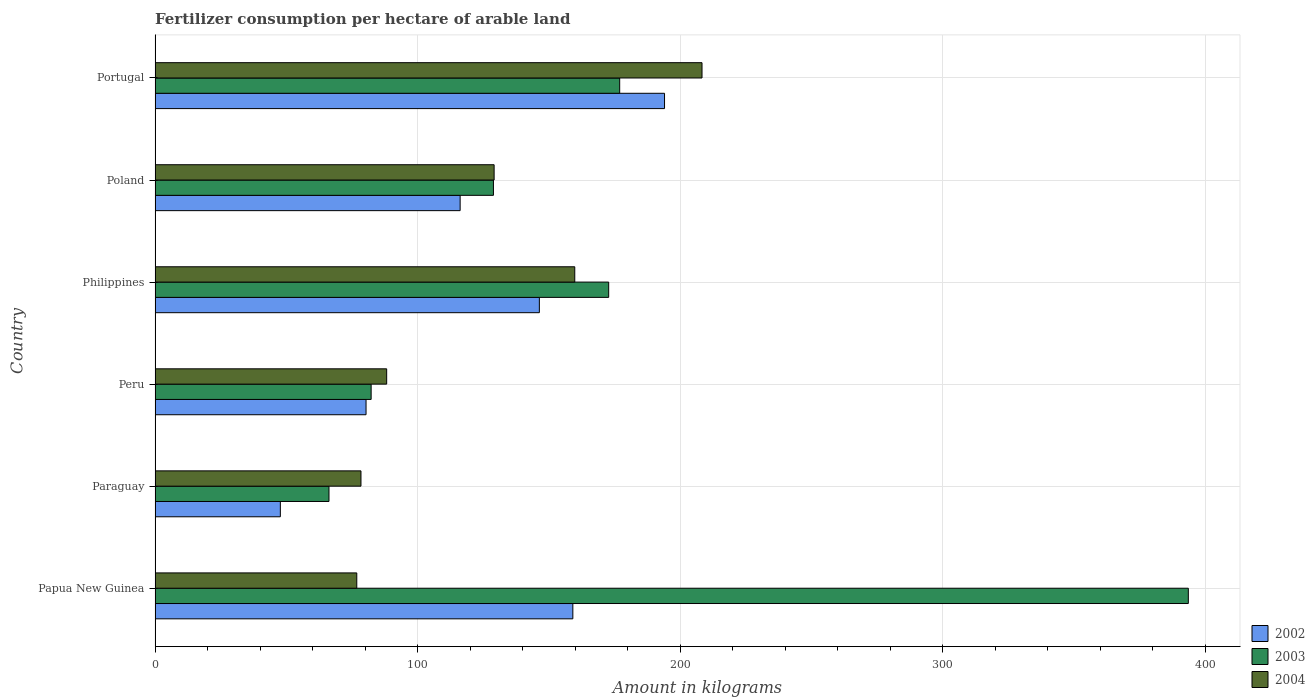How many different coloured bars are there?
Make the answer very short. 3. How many groups of bars are there?
Provide a short and direct response. 6. How many bars are there on the 6th tick from the top?
Provide a short and direct response. 3. How many bars are there on the 1st tick from the bottom?
Your answer should be compact. 3. What is the label of the 4th group of bars from the top?
Keep it short and to the point. Peru. What is the amount of fertilizer consumption in 2002 in Peru?
Your response must be concise. 80.35. Across all countries, what is the maximum amount of fertilizer consumption in 2003?
Offer a terse response. 393.53. Across all countries, what is the minimum amount of fertilizer consumption in 2002?
Your answer should be compact. 47.72. In which country was the amount of fertilizer consumption in 2003 maximum?
Provide a succinct answer. Papua New Guinea. In which country was the amount of fertilizer consumption in 2002 minimum?
Your response must be concise. Paraguay. What is the total amount of fertilizer consumption in 2003 in the graph?
Keep it short and to the point. 1020.66. What is the difference between the amount of fertilizer consumption in 2003 in Papua New Guinea and that in Peru?
Ensure brevity in your answer.  311.23. What is the difference between the amount of fertilizer consumption in 2002 in Poland and the amount of fertilizer consumption in 2003 in Paraguay?
Offer a terse response. 49.96. What is the average amount of fertilizer consumption in 2004 per country?
Offer a very short reply. 123.46. What is the difference between the amount of fertilizer consumption in 2004 and amount of fertilizer consumption in 2002 in Peru?
Offer a very short reply. 7.86. What is the ratio of the amount of fertilizer consumption in 2003 in Peru to that in Portugal?
Your response must be concise. 0.47. Is the amount of fertilizer consumption in 2004 in Philippines less than that in Portugal?
Your answer should be compact. Yes. Is the difference between the amount of fertilizer consumption in 2004 in Papua New Guinea and Peru greater than the difference between the amount of fertilizer consumption in 2002 in Papua New Guinea and Peru?
Keep it short and to the point. No. What is the difference between the highest and the second highest amount of fertilizer consumption in 2004?
Give a very brief answer. 48.47. What is the difference between the highest and the lowest amount of fertilizer consumption in 2003?
Offer a very short reply. 327.29. In how many countries, is the amount of fertilizer consumption in 2004 greater than the average amount of fertilizer consumption in 2004 taken over all countries?
Keep it short and to the point. 3. What does the 3rd bar from the top in Poland represents?
Give a very brief answer. 2002. What does the 1st bar from the bottom in Paraguay represents?
Provide a short and direct response. 2002. Is it the case that in every country, the sum of the amount of fertilizer consumption in 2003 and amount of fertilizer consumption in 2004 is greater than the amount of fertilizer consumption in 2002?
Your response must be concise. Yes. How many bars are there?
Keep it short and to the point. 18. Are all the bars in the graph horizontal?
Give a very brief answer. Yes. How many legend labels are there?
Provide a short and direct response. 3. How are the legend labels stacked?
Your answer should be very brief. Vertical. What is the title of the graph?
Make the answer very short. Fertilizer consumption per hectare of arable land. What is the label or title of the X-axis?
Ensure brevity in your answer.  Amount in kilograms. What is the Amount in kilograms of 2002 in Papua New Guinea?
Give a very brief answer. 159.12. What is the Amount in kilograms of 2003 in Papua New Guinea?
Your response must be concise. 393.53. What is the Amount in kilograms of 2004 in Papua New Guinea?
Your answer should be compact. 76.83. What is the Amount in kilograms of 2002 in Paraguay?
Keep it short and to the point. 47.72. What is the Amount in kilograms in 2003 in Paraguay?
Give a very brief answer. 66.24. What is the Amount in kilograms in 2004 in Paraguay?
Give a very brief answer. 78.42. What is the Amount in kilograms of 2002 in Peru?
Your answer should be very brief. 80.35. What is the Amount in kilograms of 2003 in Peru?
Offer a terse response. 82.3. What is the Amount in kilograms of 2004 in Peru?
Your answer should be very brief. 88.21. What is the Amount in kilograms of 2002 in Philippines?
Ensure brevity in your answer.  146.36. What is the Amount in kilograms of 2003 in Philippines?
Provide a succinct answer. 172.77. What is the Amount in kilograms in 2004 in Philippines?
Ensure brevity in your answer.  159.85. What is the Amount in kilograms in 2002 in Poland?
Give a very brief answer. 116.2. What is the Amount in kilograms in 2003 in Poland?
Ensure brevity in your answer.  128.87. What is the Amount in kilograms of 2004 in Poland?
Your answer should be compact. 129.14. What is the Amount in kilograms of 2002 in Portugal?
Ensure brevity in your answer.  194.04. What is the Amount in kilograms of 2003 in Portugal?
Offer a terse response. 176.96. What is the Amount in kilograms of 2004 in Portugal?
Provide a succinct answer. 208.31. Across all countries, what is the maximum Amount in kilograms of 2002?
Ensure brevity in your answer.  194.04. Across all countries, what is the maximum Amount in kilograms of 2003?
Provide a short and direct response. 393.53. Across all countries, what is the maximum Amount in kilograms in 2004?
Provide a short and direct response. 208.31. Across all countries, what is the minimum Amount in kilograms of 2002?
Give a very brief answer. 47.72. Across all countries, what is the minimum Amount in kilograms in 2003?
Give a very brief answer. 66.24. Across all countries, what is the minimum Amount in kilograms in 2004?
Ensure brevity in your answer.  76.83. What is the total Amount in kilograms in 2002 in the graph?
Ensure brevity in your answer.  743.78. What is the total Amount in kilograms of 2003 in the graph?
Your answer should be compact. 1020.66. What is the total Amount in kilograms of 2004 in the graph?
Make the answer very short. 740.76. What is the difference between the Amount in kilograms of 2002 in Papua New Guinea and that in Paraguay?
Provide a short and direct response. 111.4. What is the difference between the Amount in kilograms of 2003 in Papua New Guinea and that in Paraguay?
Your answer should be very brief. 327.29. What is the difference between the Amount in kilograms in 2004 in Papua New Guinea and that in Paraguay?
Provide a succinct answer. -1.6. What is the difference between the Amount in kilograms of 2002 in Papua New Guinea and that in Peru?
Your answer should be compact. 78.76. What is the difference between the Amount in kilograms of 2003 in Papua New Guinea and that in Peru?
Provide a succinct answer. 311.23. What is the difference between the Amount in kilograms of 2004 in Papua New Guinea and that in Peru?
Provide a short and direct response. -11.39. What is the difference between the Amount in kilograms of 2002 in Papua New Guinea and that in Philippines?
Your answer should be compact. 12.76. What is the difference between the Amount in kilograms in 2003 in Papua New Guinea and that in Philippines?
Your response must be concise. 220.76. What is the difference between the Amount in kilograms in 2004 in Papua New Guinea and that in Philippines?
Provide a short and direct response. -83.02. What is the difference between the Amount in kilograms in 2002 in Papua New Guinea and that in Poland?
Your answer should be compact. 42.92. What is the difference between the Amount in kilograms of 2003 in Papua New Guinea and that in Poland?
Make the answer very short. 264.66. What is the difference between the Amount in kilograms in 2004 in Papua New Guinea and that in Poland?
Give a very brief answer. -52.31. What is the difference between the Amount in kilograms in 2002 in Papua New Guinea and that in Portugal?
Your answer should be compact. -34.92. What is the difference between the Amount in kilograms in 2003 in Papua New Guinea and that in Portugal?
Give a very brief answer. 216.57. What is the difference between the Amount in kilograms of 2004 in Papua New Guinea and that in Portugal?
Give a very brief answer. -131.49. What is the difference between the Amount in kilograms in 2002 in Paraguay and that in Peru?
Make the answer very short. -32.64. What is the difference between the Amount in kilograms of 2003 in Paraguay and that in Peru?
Give a very brief answer. -16.06. What is the difference between the Amount in kilograms of 2004 in Paraguay and that in Peru?
Ensure brevity in your answer.  -9.79. What is the difference between the Amount in kilograms in 2002 in Paraguay and that in Philippines?
Give a very brief answer. -98.65. What is the difference between the Amount in kilograms in 2003 in Paraguay and that in Philippines?
Provide a short and direct response. -106.53. What is the difference between the Amount in kilograms of 2004 in Paraguay and that in Philippines?
Ensure brevity in your answer.  -81.42. What is the difference between the Amount in kilograms of 2002 in Paraguay and that in Poland?
Your answer should be compact. -68.48. What is the difference between the Amount in kilograms in 2003 in Paraguay and that in Poland?
Your answer should be very brief. -62.63. What is the difference between the Amount in kilograms of 2004 in Paraguay and that in Poland?
Keep it short and to the point. -50.71. What is the difference between the Amount in kilograms of 2002 in Paraguay and that in Portugal?
Make the answer very short. -146.32. What is the difference between the Amount in kilograms in 2003 in Paraguay and that in Portugal?
Offer a very short reply. -110.72. What is the difference between the Amount in kilograms of 2004 in Paraguay and that in Portugal?
Provide a succinct answer. -129.89. What is the difference between the Amount in kilograms of 2002 in Peru and that in Philippines?
Offer a very short reply. -66.01. What is the difference between the Amount in kilograms of 2003 in Peru and that in Philippines?
Provide a short and direct response. -90.47. What is the difference between the Amount in kilograms in 2004 in Peru and that in Philippines?
Offer a very short reply. -71.63. What is the difference between the Amount in kilograms in 2002 in Peru and that in Poland?
Provide a short and direct response. -35.84. What is the difference between the Amount in kilograms of 2003 in Peru and that in Poland?
Offer a very short reply. -46.57. What is the difference between the Amount in kilograms in 2004 in Peru and that in Poland?
Provide a short and direct response. -40.92. What is the difference between the Amount in kilograms of 2002 in Peru and that in Portugal?
Give a very brief answer. -113.68. What is the difference between the Amount in kilograms in 2003 in Peru and that in Portugal?
Make the answer very short. -94.66. What is the difference between the Amount in kilograms of 2004 in Peru and that in Portugal?
Offer a terse response. -120.1. What is the difference between the Amount in kilograms of 2002 in Philippines and that in Poland?
Ensure brevity in your answer.  30.17. What is the difference between the Amount in kilograms in 2003 in Philippines and that in Poland?
Provide a succinct answer. 43.9. What is the difference between the Amount in kilograms in 2004 in Philippines and that in Poland?
Ensure brevity in your answer.  30.71. What is the difference between the Amount in kilograms of 2002 in Philippines and that in Portugal?
Keep it short and to the point. -47.68. What is the difference between the Amount in kilograms in 2003 in Philippines and that in Portugal?
Your answer should be very brief. -4.19. What is the difference between the Amount in kilograms of 2004 in Philippines and that in Portugal?
Your answer should be compact. -48.47. What is the difference between the Amount in kilograms of 2002 in Poland and that in Portugal?
Keep it short and to the point. -77.84. What is the difference between the Amount in kilograms of 2003 in Poland and that in Portugal?
Your answer should be compact. -48.09. What is the difference between the Amount in kilograms of 2004 in Poland and that in Portugal?
Provide a short and direct response. -79.18. What is the difference between the Amount in kilograms of 2002 in Papua New Guinea and the Amount in kilograms of 2003 in Paraguay?
Keep it short and to the point. 92.88. What is the difference between the Amount in kilograms of 2002 in Papua New Guinea and the Amount in kilograms of 2004 in Paraguay?
Keep it short and to the point. 80.7. What is the difference between the Amount in kilograms in 2003 in Papua New Guinea and the Amount in kilograms in 2004 in Paraguay?
Your answer should be compact. 315.11. What is the difference between the Amount in kilograms in 2002 in Papua New Guinea and the Amount in kilograms in 2003 in Peru?
Ensure brevity in your answer.  76.82. What is the difference between the Amount in kilograms in 2002 in Papua New Guinea and the Amount in kilograms in 2004 in Peru?
Make the answer very short. 70.91. What is the difference between the Amount in kilograms of 2003 in Papua New Guinea and the Amount in kilograms of 2004 in Peru?
Ensure brevity in your answer.  305.32. What is the difference between the Amount in kilograms of 2002 in Papua New Guinea and the Amount in kilograms of 2003 in Philippines?
Provide a succinct answer. -13.65. What is the difference between the Amount in kilograms of 2002 in Papua New Guinea and the Amount in kilograms of 2004 in Philippines?
Keep it short and to the point. -0.73. What is the difference between the Amount in kilograms in 2003 in Papua New Guinea and the Amount in kilograms in 2004 in Philippines?
Provide a short and direct response. 233.68. What is the difference between the Amount in kilograms of 2002 in Papua New Guinea and the Amount in kilograms of 2003 in Poland?
Provide a succinct answer. 30.25. What is the difference between the Amount in kilograms in 2002 in Papua New Guinea and the Amount in kilograms in 2004 in Poland?
Give a very brief answer. 29.98. What is the difference between the Amount in kilograms of 2003 in Papua New Guinea and the Amount in kilograms of 2004 in Poland?
Give a very brief answer. 264.39. What is the difference between the Amount in kilograms of 2002 in Papua New Guinea and the Amount in kilograms of 2003 in Portugal?
Your answer should be compact. -17.84. What is the difference between the Amount in kilograms in 2002 in Papua New Guinea and the Amount in kilograms in 2004 in Portugal?
Provide a short and direct response. -49.2. What is the difference between the Amount in kilograms of 2003 in Papua New Guinea and the Amount in kilograms of 2004 in Portugal?
Provide a succinct answer. 185.21. What is the difference between the Amount in kilograms in 2002 in Paraguay and the Amount in kilograms in 2003 in Peru?
Make the answer very short. -34.58. What is the difference between the Amount in kilograms in 2002 in Paraguay and the Amount in kilograms in 2004 in Peru?
Offer a very short reply. -40.5. What is the difference between the Amount in kilograms of 2003 in Paraguay and the Amount in kilograms of 2004 in Peru?
Your response must be concise. -21.97. What is the difference between the Amount in kilograms of 2002 in Paraguay and the Amount in kilograms of 2003 in Philippines?
Provide a succinct answer. -125.05. What is the difference between the Amount in kilograms of 2002 in Paraguay and the Amount in kilograms of 2004 in Philippines?
Provide a short and direct response. -112.13. What is the difference between the Amount in kilograms in 2003 in Paraguay and the Amount in kilograms in 2004 in Philippines?
Give a very brief answer. -93.61. What is the difference between the Amount in kilograms of 2002 in Paraguay and the Amount in kilograms of 2003 in Poland?
Your answer should be compact. -81.16. What is the difference between the Amount in kilograms in 2002 in Paraguay and the Amount in kilograms in 2004 in Poland?
Your response must be concise. -81.42. What is the difference between the Amount in kilograms of 2003 in Paraguay and the Amount in kilograms of 2004 in Poland?
Provide a short and direct response. -62.9. What is the difference between the Amount in kilograms in 2002 in Paraguay and the Amount in kilograms in 2003 in Portugal?
Ensure brevity in your answer.  -129.24. What is the difference between the Amount in kilograms in 2002 in Paraguay and the Amount in kilograms in 2004 in Portugal?
Keep it short and to the point. -160.6. What is the difference between the Amount in kilograms of 2003 in Paraguay and the Amount in kilograms of 2004 in Portugal?
Ensure brevity in your answer.  -142.08. What is the difference between the Amount in kilograms of 2002 in Peru and the Amount in kilograms of 2003 in Philippines?
Ensure brevity in your answer.  -92.41. What is the difference between the Amount in kilograms in 2002 in Peru and the Amount in kilograms in 2004 in Philippines?
Offer a terse response. -79.49. What is the difference between the Amount in kilograms of 2003 in Peru and the Amount in kilograms of 2004 in Philippines?
Ensure brevity in your answer.  -77.55. What is the difference between the Amount in kilograms in 2002 in Peru and the Amount in kilograms in 2003 in Poland?
Offer a terse response. -48.52. What is the difference between the Amount in kilograms of 2002 in Peru and the Amount in kilograms of 2004 in Poland?
Offer a very short reply. -48.78. What is the difference between the Amount in kilograms of 2003 in Peru and the Amount in kilograms of 2004 in Poland?
Your response must be concise. -46.84. What is the difference between the Amount in kilograms in 2002 in Peru and the Amount in kilograms in 2003 in Portugal?
Your answer should be very brief. -96.6. What is the difference between the Amount in kilograms of 2002 in Peru and the Amount in kilograms of 2004 in Portugal?
Keep it short and to the point. -127.96. What is the difference between the Amount in kilograms in 2003 in Peru and the Amount in kilograms in 2004 in Portugal?
Your answer should be compact. -126.02. What is the difference between the Amount in kilograms in 2002 in Philippines and the Amount in kilograms in 2003 in Poland?
Offer a very short reply. 17.49. What is the difference between the Amount in kilograms of 2002 in Philippines and the Amount in kilograms of 2004 in Poland?
Keep it short and to the point. 17.23. What is the difference between the Amount in kilograms of 2003 in Philippines and the Amount in kilograms of 2004 in Poland?
Keep it short and to the point. 43.63. What is the difference between the Amount in kilograms in 2002 in Philippines and the Amount in kilograms in 2003 in Portugal?
Make the answer very short. -30.6. What is the difference between the Amount in kilograms in 2002 in Philippines and the Amount in kilograms in 2004 in Portugal?
Your answer should be very brief. -61.95. What is the difference between the Amount in kilograms of 2003 in Philippines and the Amount in kilograms of 2004 in Portugal?
Provide a short and direct response. -35.55. What is the difference between the Amount in kilograms in 2002 in Poland and the Amount in kilograms in 2003 in Portugal?
Offer a terse response. -60.76. What is the difference between the Amount in kilograms of 2002 in Poland and the Amount in kilograms of 2004 in Portugal?
Ensure brevity in your answer.  -92.12. What is the difference between the Amount in kilograms of 2003 in Poland and the Amount in kilograms of 2004 in Portugal?
Offer a very short reply. -79.44. What is the average Amount in kilograms in 2002 per country?
Ensure brevity in your answer.  123.96. What is the average Amount in kilograms in 2003 per country?
Offer a terse response. 170.11. What is the average Amount in kilograms in 2004 per country?
Keep it short and to the point. 123.46. What is the difference between the Amount in kilograms in 2002 and Amount in kilograms in 2003 in Papua New Guinea?
Your answer should be compact. -234.41. What is the difference between the Amount in kilograms of 2002 and Amount in kilograms of 2004 in Papua New Guinea?
Your answer should be compact. 82.29. What is the difference between the Amount in kilograms in 2003 and Amount in kilograms in 2004 in Papua New Guinea?
Offer a very short reply. 316.7. What is the difference between the Amount in kilograms in 2002 and Amount in kilograms in 2003 in Paraguay?
Your answer should be compact. -18.52. What is the difference between the Amount in kilograms of 2002 and Amount in kilograms of 2004 in Paraguay?
Provide a short and direct response. -30.71. What is the difference between the Amount in kilograms of 2003 and Amount in kilograms of 2004 in Paraguay?
Provide a succinct answer. -12.18. What is the difference between the Amount in kilograms of 2002 and Amount in kilograms of 2003 in Peru?
Provide a short and direct response. -1.94. What is the difference between the Amount in kilograms in 2002 and Amount in kilograms in 2004 in Peru?
Your response must be concise. -7.86. What is the difference between the Amount in kilograms in 2003 and Amount in kilograms in 2004 in Peru?
Offer a terse response. -5.91. What is the difference between the Amount in kilograms of 2002 and Amount in kilograms of 2003 in Philippines?
Give a very brief answer. -26.41. What is the difference between the Amount in kilograms in 2002 and Amount in kilograms in 2004 in Philippines?
Ensure brevity in your answer.  -13.48. What is the difference between the Amount in kilograms of 2003 and Amount in kilograms of 2004 in Philippines?
Your answer should be compact. 12.92. What is the difference between the Amount in kilograms of 2002 and Amount in kilograms of 2003 in Poland?
Your response must be concise. -12.68. What is the difference between the Amount in kilograms of 2002 and Amount in kilograms of 2004 in Poland?
Your response must be concise. -12.94. What is the difference between the Amount in kilograms in 2003 and Amount in kilograms in 2004 in Poland?
Ensure brevity in your answer.  -0.26. What is the difference between the Amount in kilograms of 2002 and Amount in kilograms of 2003 in Portugal?
Offer a terse response. 17.08. What is the difference between the Amount in kilograms of 2002 and Amount in kilograms of 2004 in Portugal?
Your answer should be compact. -14.28. What is the difference between the Amount in kilograms of 2003 and Amount in kilograms of 2004 in Portugal?
Offer a terse response. -31.36. What is the ratio of the Amount in kilograms in 2002 in Papua New Guinea to that in Paraguay?
Provide a short and direct response. 3.33. What is the ratio of the Amount in kilograms in 2003 in Papua New Guinea to that in Paraguay?
Your answer should be compact. 5.94. What is the ratio of the Amount in kilograms of 2004 in Papua New Guinea to that in Paraguay?
Your answer should be compact. 0.98. What is the ratio of the Amount in kilograms in 2002 in Papua New Guinea to that in Peru?
Ensure brevity in your answer.  1.98. What is the ratio of the Amount in kilograms of 2003 in Papua New Guinea to that in Peru?
Make the answer very short. 4.78. What is the ratio of the Amount in kilograms of 2004 in Papua New Guinea to that in Peru?
Make the answer very short. 0.87. What is the ratio of the Amount in kilograms in 2002 in Papua New Guinea to that in Philippines?
Your answer should be compact. 1.09. What is the ratio of the Amount in kilograms of 2003 in Papua New Guinea to that in Philippines?
Provide a short and direct response. 2.28. What is the ratio of the Amount in kilograms of 2004 in Papua New Guinea to that in Philippines?
Keep it short and to the point. 0.48. What is the ratio of the Amount in kilograms of 2002 in Papua New Guinea to that in Poland?
Your response must be concise. 1.37. What is the ratio of the Amount in kilograms in 2003 in Papua New Guinea to that in Poland?
Your response must be concise. 3.05. What is the ratio of the Amount in kilograms of 2004 in Papua New Guinea to that in Poland?
Make the answer very short. 0.59. What is the ratio of the Amount in kilograms of 2002 in Papua New Guinea to that in Portugal?
Your response must be concise. 0.82. What is the ratio of the Amount in kilograms in 2003 in Papua New Guinea to that in Portugal?
Provide a short and direct response. 2.22. What is the ratio of the Amount in kilograms of 2004 in Papua New Guinea to that in Portugal?
Ensure brevity in your answer.  0.37. What is the ratio of the Amount in kilograms in 2002 in Paraguay to that in Peru?
Your answer should be very brief. 0.59. What is the ratio of the Amount in kilograms in 2003 in Paraguay to that in Peru?
Your answer should be very brief. 0.8. What is the ratio of the Amount in kilograms of 2004 in Paraguay to that in Peru?
Your answer should be compact. 0.89. What is the ratio of the Amount in kilograms in 2002 in Paraguay to that in Philippines?
Offer a terse response. 0.33. What is the ratio of the Amount in kilograms in 2003 in Paraguay to that in Philippines?
Offer a very short reply. 0.38. What is the ratio of the Amount in kilograms of 2004 in Paraguay to that in Philippines?
Ensure brevity in your answer.  0.49. What is the ratio of the Amount in kilograms in 2002 in Paraguay to that in Poland?
Keep it short and to the point. 0.41. What is the ratio of the Amount in kilograms in 2003 in Paraguay to that in Poland?
Give a very brief answer. 0.51. What is the ratio of the Amount in kilograms of 2004 in Paraguay to that in Poland?
Provide a succinct answer. 0.61. What is the ratio of the Amount in kilograms of 2002 in Paraguay to that in Portugal?
Your answer should be very brief. 0.25. What is the ratio of the Amount in kilograms of 2003 in Paraguay to that in Portugal?
Offer a terse response. 0.37. What is the ratio of the Amount in kilograms in 2004 in Paraguay to that in Portugal?
Your answer should be very brief. 0.38. What is the ratio of the Amount in kilograms of 2002 in Peru to that in Philippines?
Offer a very short reply. 0.55. What is the ratio of the Amount in kilograms of 2003 in Peru to that in Philippines?
Offer a terse response. 0.48. What is the ratio of the Amount in kilograms of 2004 in Peru to that in Philippines?
Offer a very short reply. 0.55. What is the ratio of the Amount in kilograms in 2002 in Peru to that in Poland?
Your response must be concise. 0.69. What is the ratio of the Amount in kilograms of 2003 in Peru to that in Poland?
Keep it short and to the point. 0.64. What is the ratio of the Amount in kilograms in 2004 in Peru to that in Poland?
Ensure brevity in your answer.  0.68. What is the ratio of the Amount in kilograms of 2002 in Peru to that in Portugal?
Provide a short and direct response. 0.41. What is the ratio of the Amount in kilograms of 2003 in Peru to that in Portugal?
Your answer should be compact. 0.47. What is the ratio of the Amount in kilograms in 2004 in Peru to that in Portugal?
Your response must be concise. 0.42. What is the ratio of the Amount in kilograms in 2002 in Philippines to that in Poland?
Your answer should be very brief. 1.26. What is the ratio of the Amount in kilograms in 2003 in Philippines to that in Poland?
Ensure brevity in your answer.  1.34. What is the ratio of the Amount in kilograms in 2004 in Philippines to that in Poland?
Provide a short and direct response. 1.24. What is the ratio of the Amount in kilograms in 2002 in Philippines to that in Portugal?
Provide a succinct answer. 0.75. What is the ratio of the Amount in kilograms in 2003 in Philippines to that in Portugal?
Provide a short and direct response. 0.98. What is the ratio of the Amount in kilograms of 2004 in Philippines to that in Portugal?
Offer a very short reply. 0.77. What is the ratio of the Amount in kilograms of 2002 in Poland to that in Portugal?
Provide a short and direct response. 0.6. What is the ratio of the Amount in kilograms in 2003 in Poland to that in Portugal?
Your response must be concise. 0.73. What is the ratio of the Amount in kilograms of 2004 in Poland to that in Portugal?
Your answer should be very brief. 0.62. What is the difference between the highest and the second highest Amount in kilograms in 2002?
Give a very brief answer. 34.92. What is the difference between the highest and the second highest Amount in kilograms in 2003?
Offer a terse response. 216.57. What is the difference between the highest and the second highest Amount in kilograms in 2004?
Your answer should be very brief. 48.47. What is the difference between the highest and the lowest Amount in kilograms of 2002?
Your answer should be very brief. 146.32. What is the difference between the highest and the lowest Amount in kilograms of 2003?
Offer a very short reply. 327.29. What is the difference between the highest and the lowest Amount in kilograms of 2004?
Provide a succinct answer. 131.49. 